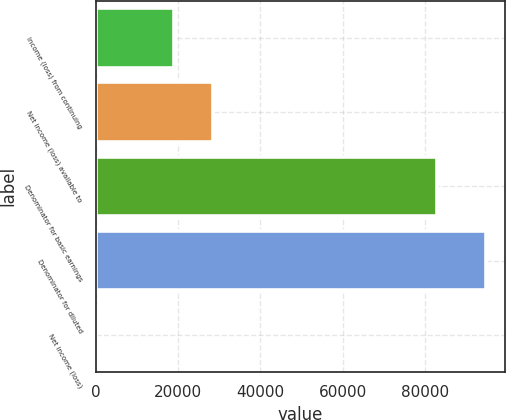<chart> <loc_0><loc_0><loc_500><loc_500><bar_chart><fcel>Income (loss) from continuing<fcel>Net income (loss) available to<fcel>Denominator for basic earnings<fcel>Denominator for diluted<fcel>Net income (loss)<nl><fcel>18970.3<fcel>28455<fcel>82960<fcel>94848<fcel>0.91<nl></chart> 